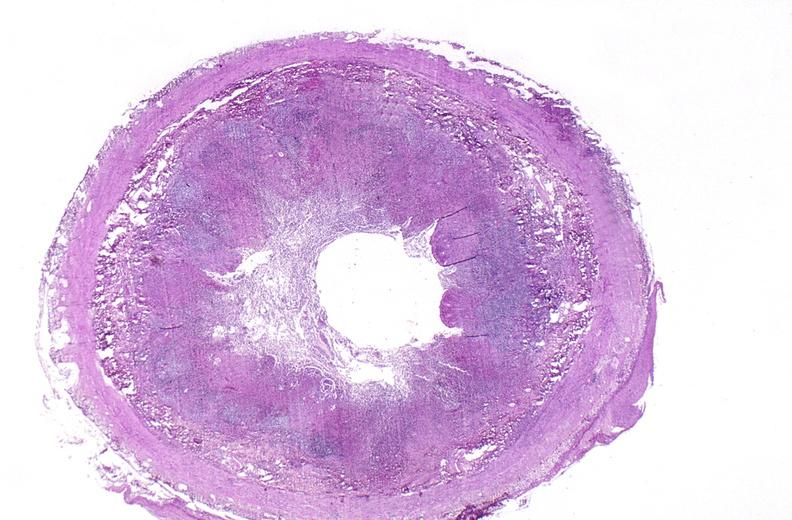what is present?
Answer the question using a single word or phrase. Gastrointestinal 